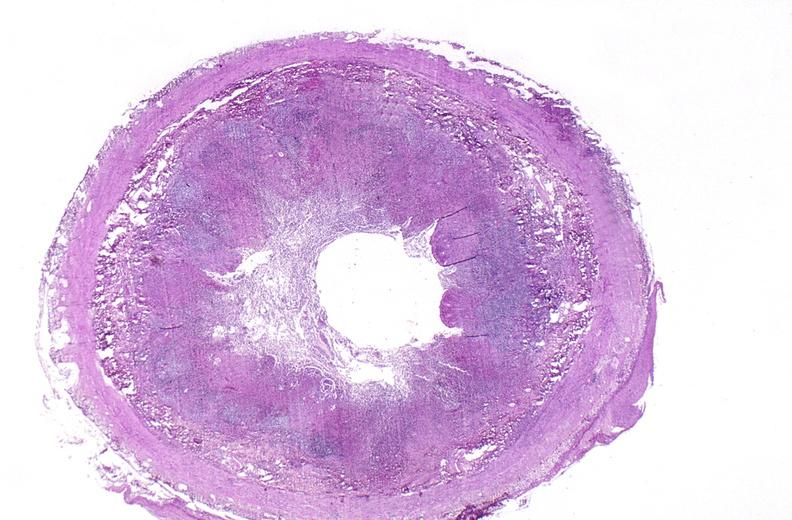what is present?
Answer the question using a single word or phrase. Gastrointestinal 